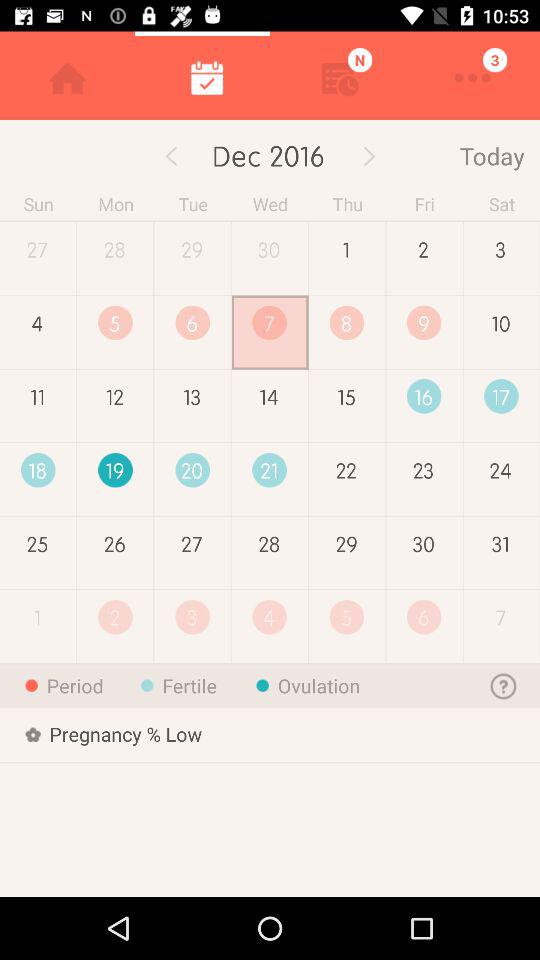What is the selected date? The selected date is Wednesday, December 7, 2017. 